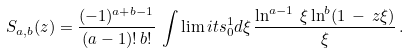<formula> <loc_0><loc_0><loc_500><loc_500>S _ { a , b } ( z ) = \frac { ( - 1 ) ^ { a + b - 1 } } { ( a - 1 ) ! \, b ! } \, \int \lim i t s _ { 0 } ^ { 1 } d \xi \, \frac { \ln ^ { a - 1 } \, \xi \ln ^ { b } ( 1 \, - \, z \xi ) } { \xi } \, .</formula> 